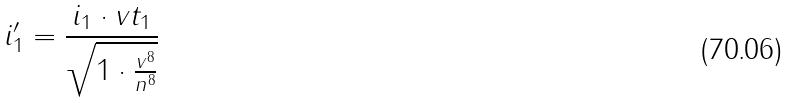<formula> <loc_0><loc_0><loc_500><loc_500>i _ { 1 } ^ { \prime } = \frac { i _ { 1 } \cdot v t _ { 1 } } { \sqrt { 1 \cdot \frac { v ^ { 8 } } { n ^ { 8 } } } }</formula> 